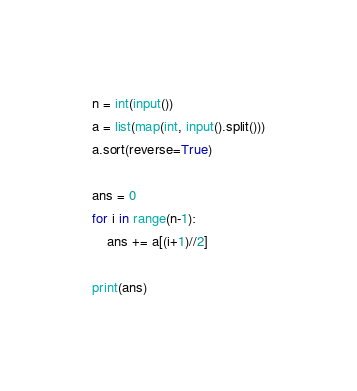<code> <loc_0><loc_0><loc_500><loc_500><_Python_>n = int(input())
a = list(map(int, input().split()))
a.sort(reverse=True)

ans = 0
for i in range(n-1):
    ans += a[(i+1)//2]

print(ans)</code> 